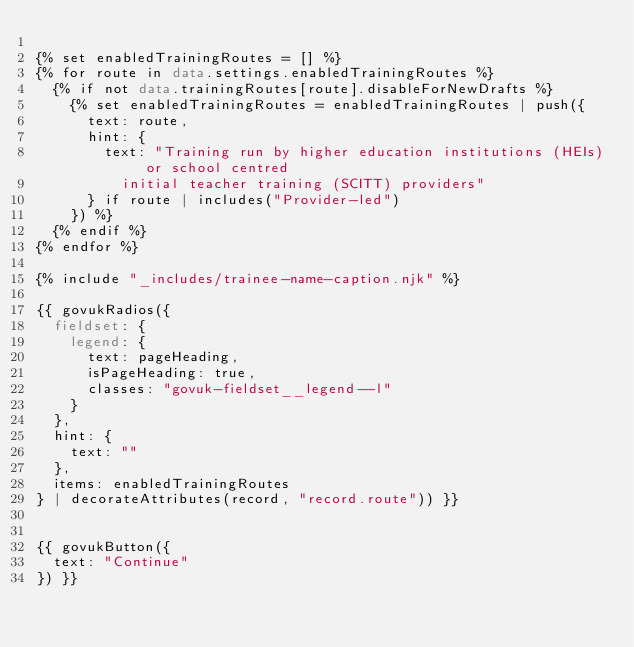<code> <loc_0><loc_0><loc_500><loc_500><_HTML_>
{% set enabledTrainingRoutes = [] %}
{% for route in data.settings.enabledTrainingRoutes %}
  {% if not data.trainingRoutes[route].disableForNewDrafts %}
    {% set enabledTrainingRoutes = enabledTrainingRoutes | push({
      text: route,
      hint: {
        text: "Training run by higher education institutions (HEIs) or school centred
          initial teacher training (SCITT) providers"
      } if route | includes("Provider-led")
    }) %}
  {% endif %}
{% endfor %}

{% include "_includes/trainee-name-caption.njk" %}

{{ govukRadios({
  fieldset: {
    legend: {
      text: pageHeading,
      isPageHeading: true,
      classes: "govuk-fieldset__legend--l"
    }
  },
  hint: {
    text: ""
  },
  items: enabledTrainingRoutes
} | decorateAttributes(record, "record.route")) }}


{{ govukButton({
  text: "Continue"
}) }}

</code> 